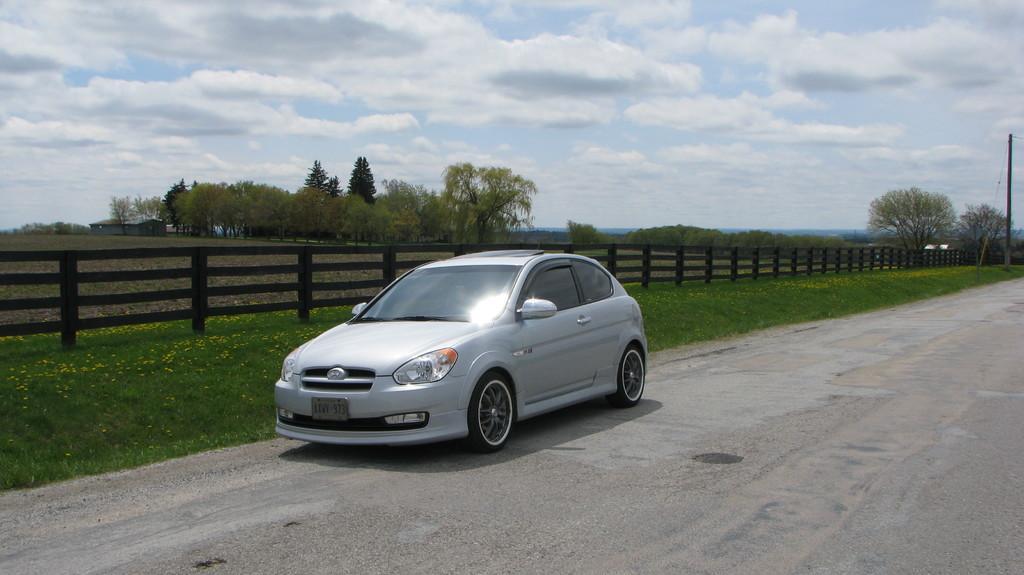Can you describe this image briefly? This image is taken outdoors. At the top of the image there is a sky with clouds. At the bottom of the image there is a road. In the background there are a few trees and plants on the ground and there is a ground with grass on it. There is a fence. On the right side of the image there is a pole. In the middle of the image a car is moving on the road. 